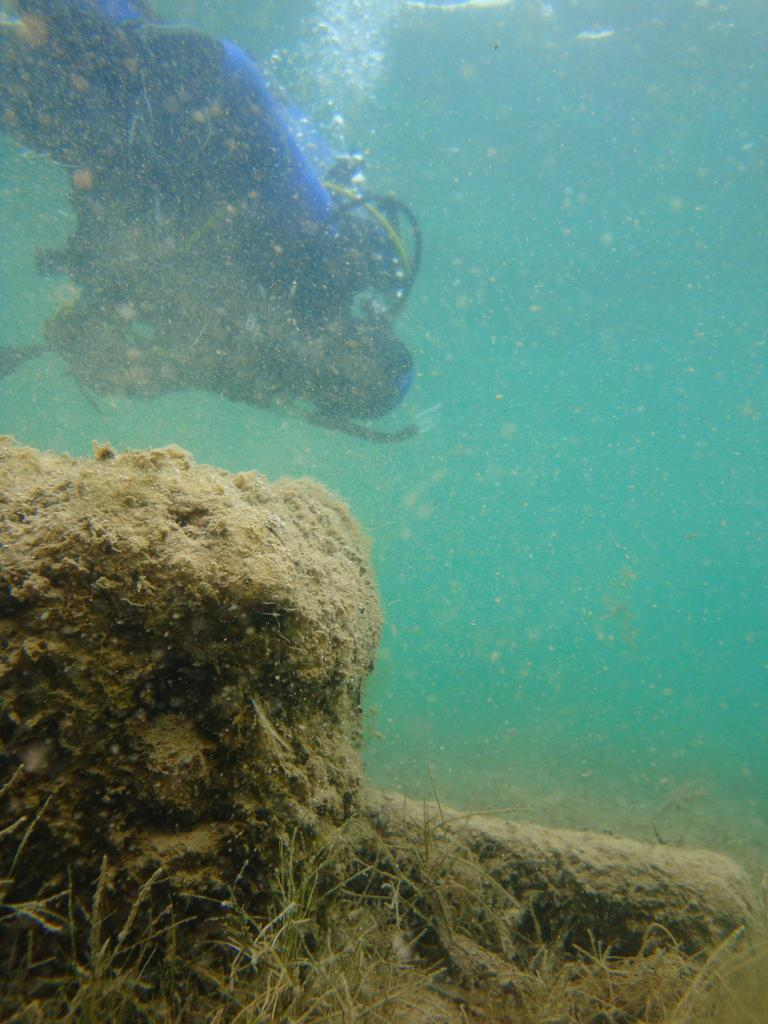Who is present in the image? There is a man in the image. What is the man wearing? The man is wearing a blue costume. What additional equipment does the man have? The man has an oxygen cylinder. Where is the man located in the image? The man is under the sea water. What can be seen in the front bottom side of the image? There is mud and dry grass in the front bottom side of the image. What type of blade is the secretary using to cut the wilderness in the image? There is no secretary or wilderness present in the image. The image features a man under the sea water with an oxygen cylinder, and there is mud and dry grass in the front bottom side of the image. 